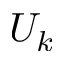<formula> <loc_0><loc_0><loc_500><loc_500>U _ { k }</formula> 